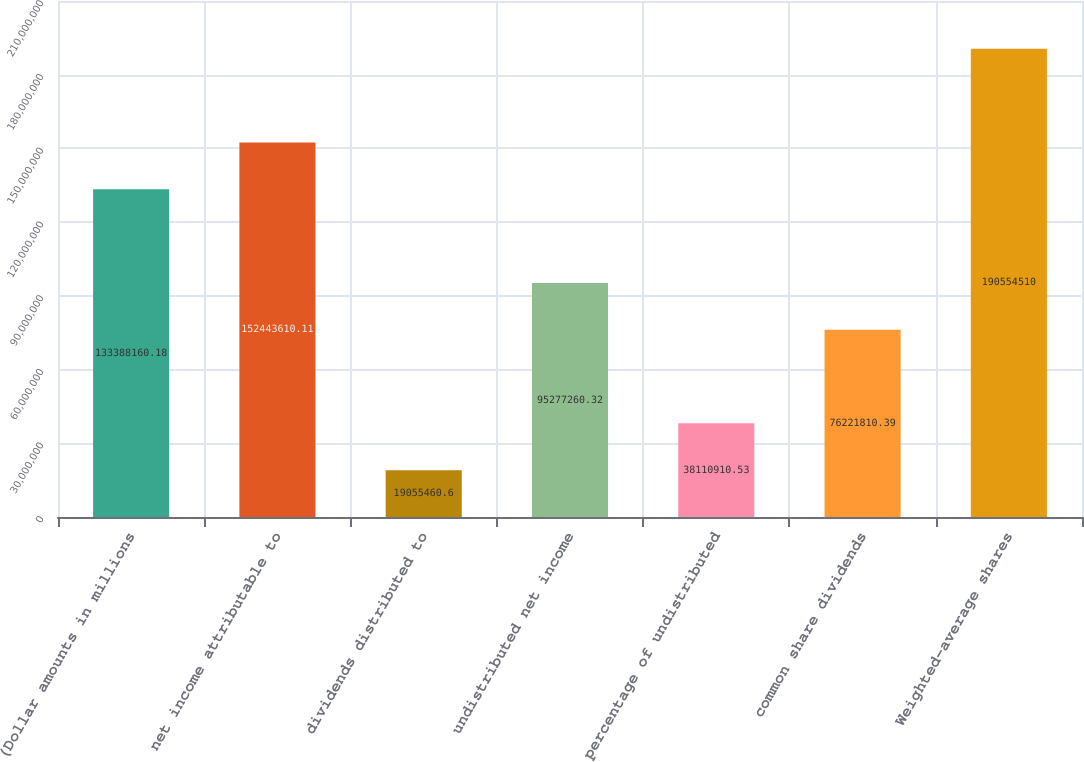Convert chart to OTSL. <chart><loc_0><loc_0><loc_500><loc_500><bar_chart><fcel>(Dollar amounts in millions<fcel>net income attributable to<fcel>dividends distributed to<fcel>undistributed net income<fcel>percentage of undistributed<fcel>common share dividends<fcel>Weighted-average shares<nl><fcel>1.33388e+08<fcel>1.52444e+08<fcel>1.90555e+07<fcel>9.52773e+07<fcel>3.81109e+07<fcel>7.62218e+07<fcel>1.90555e+08<nl></chart> 